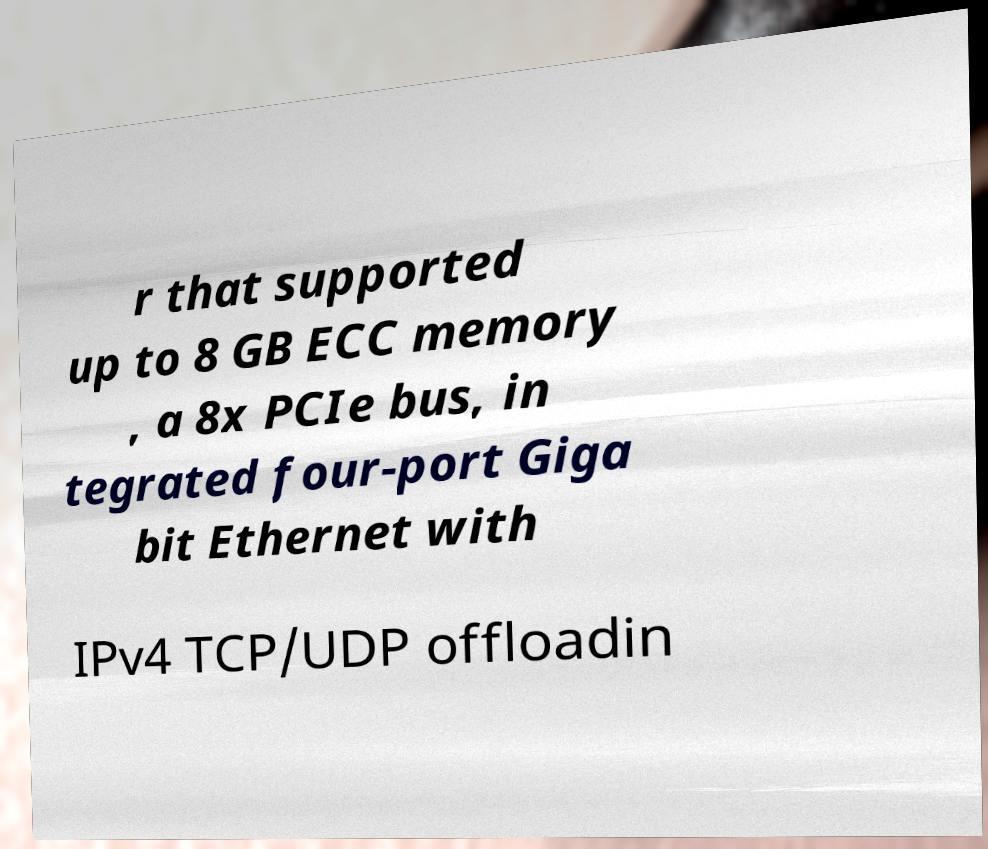I need the written content from this picture converted into text. Can you do that? r that supported up to 8 GB ECC memory , a 8x PCIe bus, in tegrated four-port Giga bit Ethernet with IPv4 TCP/UDP offloadin 